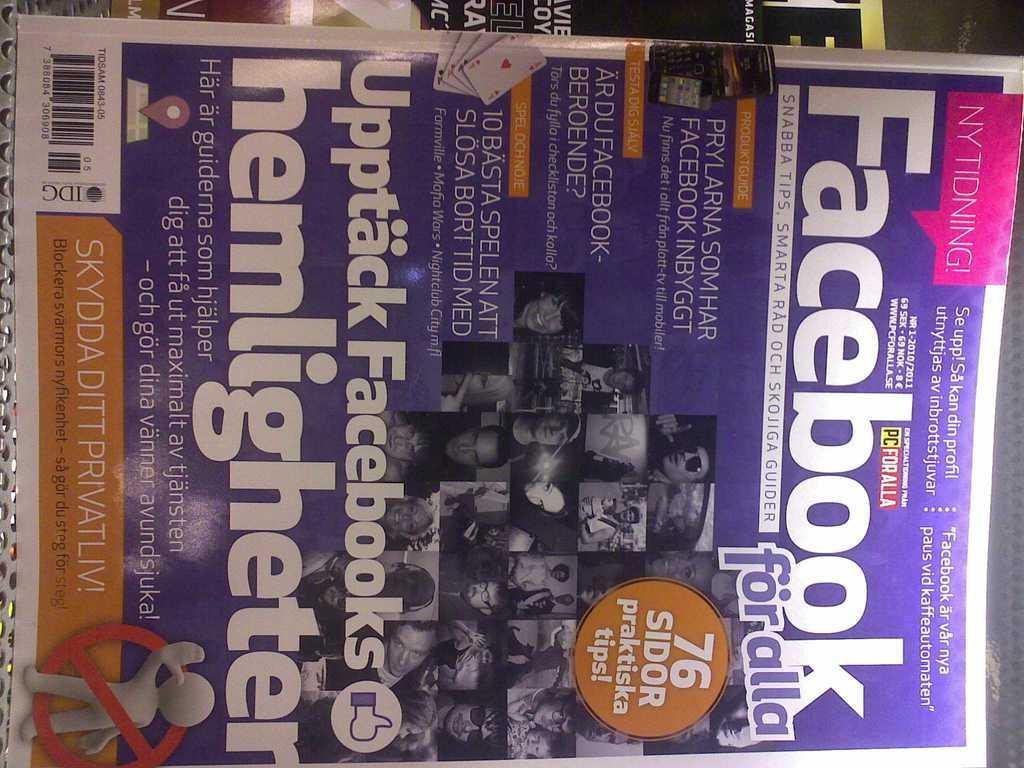<image>
Write a terse but informative summary of the picture. The magazine has several headlines in a foreign language with the only English word being Facebook. 